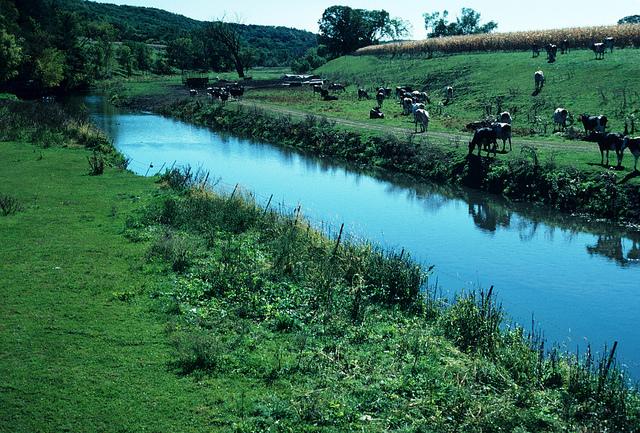What is cast?
Answer briefly. Reflection. Is this a fast moving river?
Write a very short answer. No. Is that a lot of water?
Short answer required. Yes. Would animals drink from this water?
Quick response, please. Yes. 